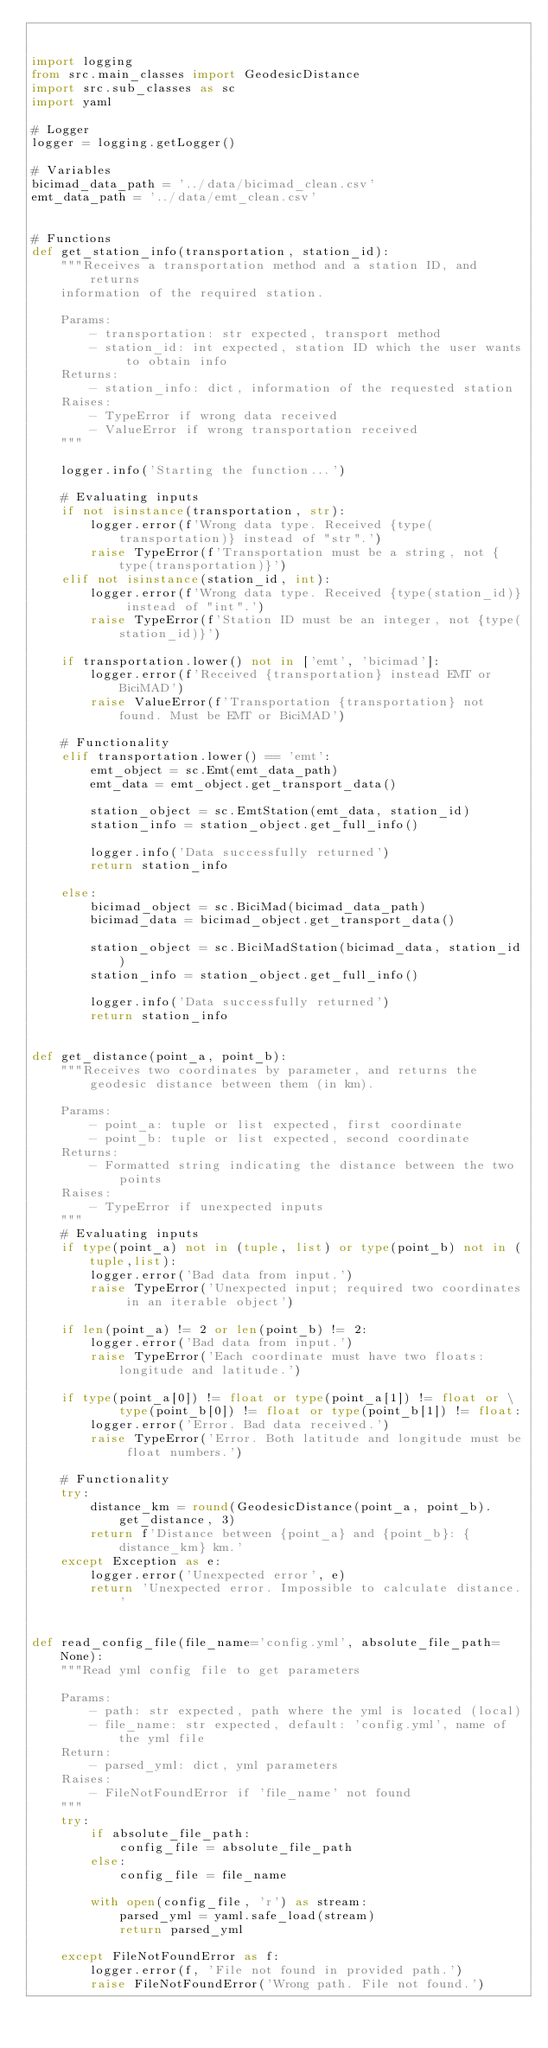Convert code to text. <code><loc_0><loc_0><loc_500><loc_500><_Python_>

import logging
from src.main_classes import GeodesicDistance
import src.sub_classes as sc
import yaml

# Logger
logger = logging.getLogger()

# Variables
bicimad_data_path = '../data/bicimad_clean.csv'
emt_data_path = '../data/emt_clean.csv'


# Functions
def get_station_info(transportation, station_id):
    """Receives a transportation method and a station ID, and returns
    information of the required station.

    Params:
        - transportation: str expected, transport method
        - station_id: int expected, station ID which the user wants to obtain info
    Returns:
        - station_info: dict, information of the requested station
    Raises:
        - TypeError if wrong data received
        - ValueError if wrong transportation received
    """

    logger.info('Starting the function...')

    # Evaluating inputs
    if not isinstance(transportation, str):
        logger.error(f'Wrong data type. Received {type(transportation)} instead of "str".')
        raise TypeError(f'Transportation must be a string, not {type(transportation)}')
    elif not isinstance(station_id, int):
        logger.error(f'Wrong data type. Received {type(station_id)} instead of "int".')
        raise TypeError(f'Station ID must be an integer, not {type(station_id)}')

    if transportation.lower() not in ['emt', 'bicimad']:
        logger.error(f'Received {transportation} instead EMT or BiciMAD')
        raise ValueError(f'Transportation {transportation} not found. Must be EMT or BiciMAD')

    # Functionality
    elif transportation.lower() == 'emt':
        emt_object = sc.Emt(emt_data_path)
        emt_data = emt_object.get_transport_data()

        station_object = sc.EmtStation(emt_data, station_id)
        station_info = station_object.get_full_info()

        logger.info('Data successfully returned')
        return station_info

    else:
        bicimad_object = sc.BiciMad(bicimad_data_path)
        bicimad_data = bicimad_object.get_transport_data()

        station_object = sc.BiciMadStation(bicimad_data, station_id)
        station_info = station_object.get_full_info()

        logger.info('Data successfully returned')
        return station_info


def get_distance(point_a, point_b):
    """Receives two coordinates by parameter, and returns the geodesic distance between them (in km).

    Params:
        - point_a: tuple or list expected, first coordinate
        - point_b: tuple or list expected, second coordinate
    Returns:
        - Formatted string indicating the distance between the two points
    Raises:
        - TypeError if unexpected inputs
    """
    # Evaluating inputs
    if type(point_a) not in (tuple, list) or type(point_b) not in (tuple,list):
        logger.error('Bad data from input.')
        raise TypeError('Unexpected input; required two coordinates in an iterable object')

    if len(point_a) != 2 or len(point_b) != 2:
        logger.error('Bad data from input.')
        raise TypeError('Each coordinate must have two floats: longitude and latitude.')

    if type(point_a[0]) != float or type(point_a[1]) != float or \
            type(point_b[0]) != float or type(point_b[1]) != float:
        logger.error('Error. Bad data received.')
        raise TypeError('Error. Both latitude and longitude must be float numbers.')

    # Functionality
    try:
        distance_km = round(GeodesicDistance(point_a, point_b).get_distance, 3)
        return f'Distance between {point_a} and {point_b}: {distance_km} km.'
    except Exception as e:
        logger.error('Unexpected error', e)
        return 'Unexpected error. Impossible to calculate distance.'


def read_config_file(file_name='config.yml', absolute_file_path=None):
    """Read yml config file to get parameters

    Params:
        - path: str expected, path where the yml is located (local)
        - file_name: str expected, default: 'config.yml', name of the yml file
    Return:
        - parsed_yml: dict, yml parameters
    Raises:
        - FileNotFoundError if 'file_name' not found
    """
    try:
        if absolute_file_path:
            config_file = absolute_file_path
        else:
            config_file = file_name

        with open(config_file, 'r') as stream:
            parsed_yml = yaml.safe_load(stream)
            return parsed_yml

    except FileNotFoundError as f:
        logger.error(f, 'File not found in provided path.')
        raise FileNotFoundError('Wrong path. File not found.')

</code> 